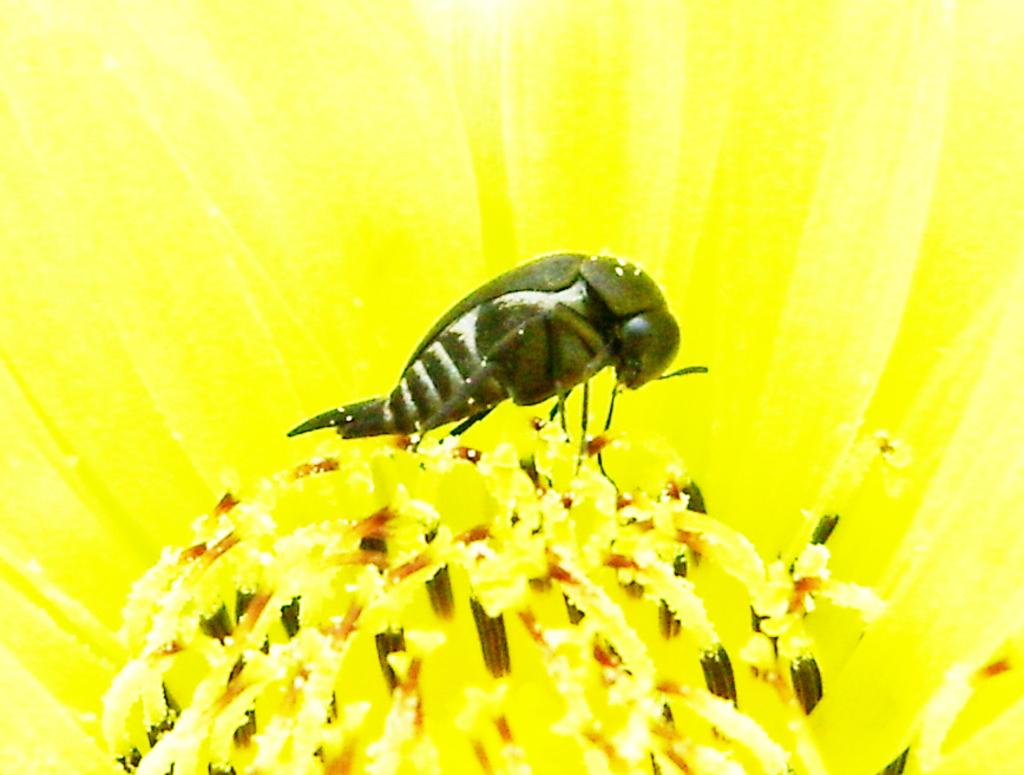What is present on the flower in the image? There is an insect on the flower in the image. Can you describe the insect's location on the flower? The insect is on the flower in the image. What type of suit is the insect wearing in the image? There is no suit present in the image, as insects do not wear clothing. 